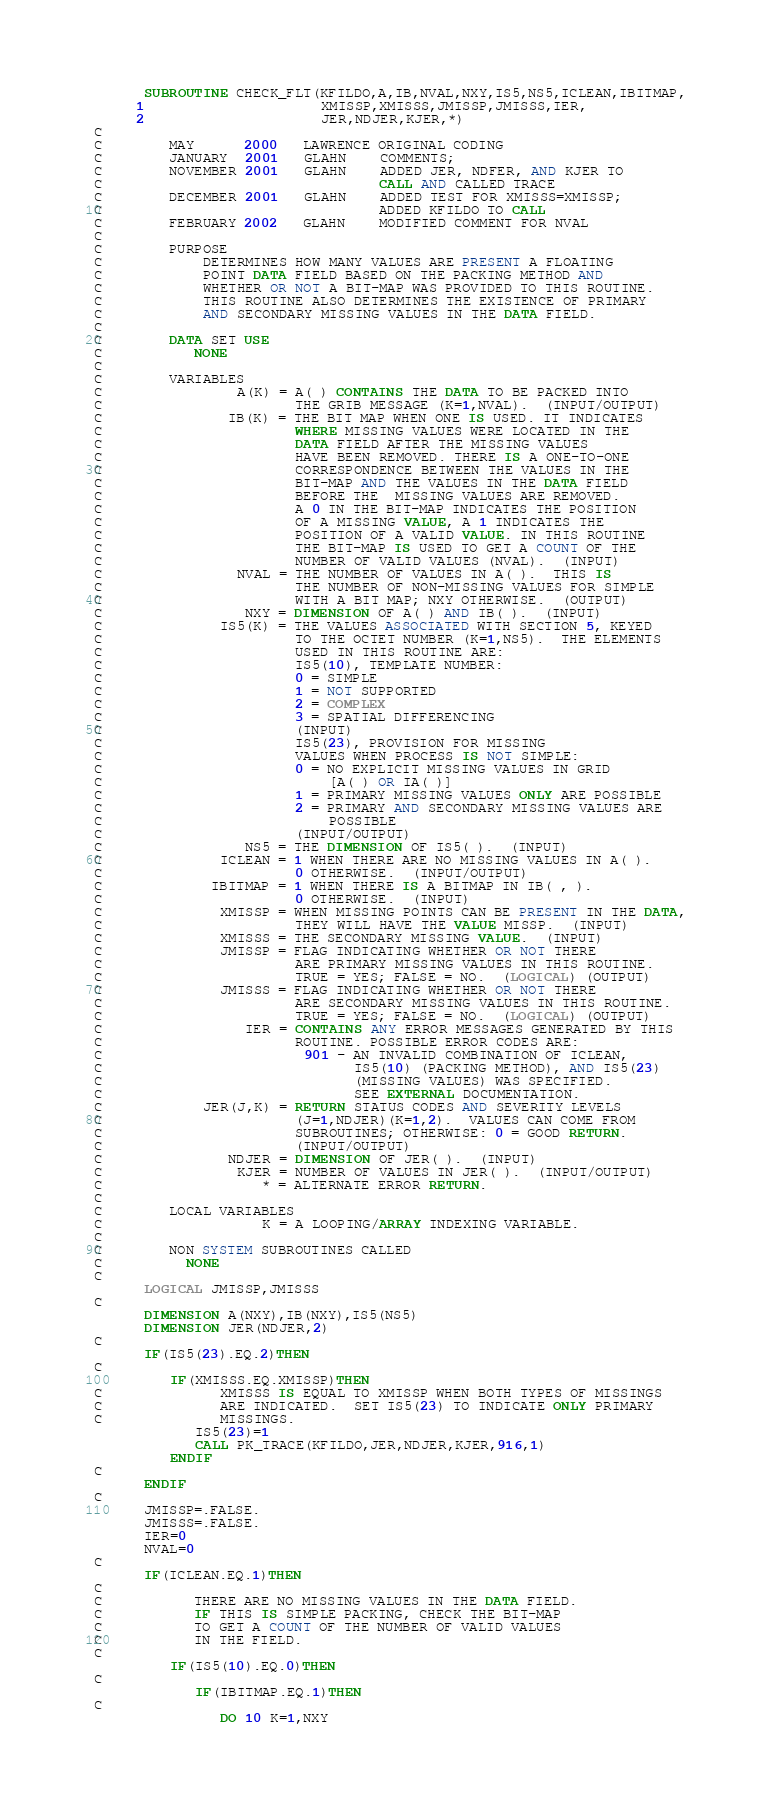<code> <loc_0><loc_0><loc_500><loc_500><_FORTRAN_>      SUBROUTINE CHECK_FLT(KFILDO,A,IB,NVAL,NXY,IS5,NS5,ICLEAN,IBITMAP,
     1                     XMISSP,XMISSS,JMISSP,JMISSS,IER,
     2                     JER,NDJER,KJER,*)
C
C        MAY      2000   LAWRENCE ORIGINAL CODING
C        JANUARY  2001   GLAHN    COMMENTS;
C        NOVEMBER 2001   GLAHN    ADDED JER, NDFER, AND KJER TO
C                                 CALL AND CALLED TRACE
C        DECEMBER 2001   GLAHN    ADDED TEST FOR XMISSS=XMISSP;
C                                 ADDED KFILDO TO CALL
C        FEBRUARY 2002   GLAHN    MODIFIED COMMENT FOR NVAL
C
C        PURPOSE
C            DETERMINES HOW MANY VALUES ARE PRESENT A FLOATING 
C            POINT DATA FIELD BASED ON THE PACKING METHOD AND
C            WHETHER OR NOT A BIT-MAP WAS PROVIDED TO THIS ROUTINE.
C            THIS ROUTINE ALSO DETERMINES THE EXISTENCE OF PRIMARY
C            AND SECONDARY MISSING VALUES IN THE DATA FIELD.
C
C        DATA SET USE
C           NONE
C
C        VARIABLES
C                A(K) = A( ) CONTAINS THE DATA TO BE PACKED INTO 
C                       THE GRIB MESSAGE (K=1,NVAL).  (INPUT/OUTPUT)
C               IB(K) = THE BIT MAP WHEN ONE IS USED. IT INDICATES
C                       WHERE MISSING VALUES WERE LOCATED IN THE 
C                       DATA FIELD AFTER THE MISSING VALUES
C                       HAVE BEEN REMOVED. THERE IS A ONE-TO-ONE
C                       CORRESPONDENCE BETWEEN THE VALUES IN THE
C                       BIT-MAP AND THE VALUES IN THE DATA FIELD
C                       BEFORE THE  MISSING VALUES ARE REMOVED.
C                       A 0 IN THE BIT-MAP INDICATES THE POSITION
C                       OF A MISSING VALUE, A 1 INDICATES THE
C                       POSITION OF A VALID VALUE. IN THIS ROUTINE
C                       THE BIT-MAP IS USED TO GET A COUNT OF THE
C                       NUMBER OF VALID VALUES (NVAL).  (INPUT)
C                NVAL = THE NUMBER OF VALUES IN A( ).  THIS IS
C                       THE NUMBER OF NON-MISSING VALUES FOR SIMPLE
C                       WITH A BIT MAP; NXY OTHERWISE.  (OUTPUT)
C                 NXY = DIMENSION OF A( ) AND IB( ).  (INPUT)
C              IS5(K) = THE VALUES ASSOCIATED WITH SECTION 5, KEYED
C                       TO THE OCTET NUMBER (K=1,NS5).  THE ELEMENTS
C                       USED IN THIS ROUTINE ARE:
C                       IS5(10), TEMPLATE NUMBER:
C                       0 = SIMPLE
C                       1 = NOT SUPPORTED
C                       2 = COMPLEX
C                       3 = SPATIAL DIFFERENCING
C                       (INPUT)
C                       IS5(23), PROVISION FOR MISSING
C                       VALUES WHEN PROCESS IS NOT SIMPLE:
C                       0 = NO EXPLICIT MISSING VALUES IN GRID 
C                           [A( ) OR IA( )]
C                       1 = PRIMARY MISSING VALUES ONLY ARE POSSIBLE
C                       2 = PRIMARY AND SECONDARY MISSING VALUES ARE
C                           POSSIBLE
C                       (INPUT/OUTPUT)
C                 NS5 = THE DIMENSION OF IS5( ).  (INPUT)
C              ICLEAN = 1 WHEN THERE ARE NO MISSING VALUES IN A( ).
C                       0 OTHERWISE.  (INPUT/OUTPUT)
C             IBITMAP = 1 WHEN THERE IS A BITMAP IN IB( , ).
C                       0 OTHERWISE.  (INPUT)
C              XMISSP = WHEN MISSING POINTS CAN BE PRESENT IN THE DATA,
C                       THEY WILL HAVE THE VALUE MISSP.  (INPUT)
C              XMISSS = THE SECONDARY MISSING VALUE.  (INPUT)
C              JMISSP = FLAG INDICATING WHETHER OR NOT THERE
C                       ARE PRIMARY MISSING VALUES IN THIS ROUTINE.
C                       TRUE = YES; FALSE = NO.  (LOGICAL) (OUTPUT)
C              JMISSS = FLAG INDICATING WHETHER OR NOT THERE
C                       ARE SECONDARY MISSING VALUES IN THIS ROUTINE.
C                       TRUE = YES; FALSE = NO.  (LOGICAL) (OUTPUT)
C                 IER = CONTAINS ANY ERROR MESSAGES GENERATED BY THIS
C                       ROUTINE. POSSIBLE ERROR CODES ARE:
C                        901 - AN INVALID COMBINATION OF ICLEAN, 
C                              IS5(10) (PACKING METHOD), AND IS5(23)
C                              (MISSING VALUES) WAS SPECIFIED.
C                              SEE EXTERNAL DOCUMENTATION.
C            JER(J,K) = RETURN STATUS CODES AND SEVERITY LEVELS
C                       (J=1,NDJER)(K=1,2).  VALUES CAN COME FROM
C                       SUBROUTINES; OTHERWISE: 0 = GOOD RETURN.
C                       (INPUT/OUTPUT)
C               NDJER = DIMENSION OF JER( ).  (INPUT)
C                KJER = NUMBER OF VALUES IN JER( ).  (INPUT/OUTPUT)
C                   * = ALTERNATE ERROR RETURN.
C
C        LOCAL VARIABLES
C                   K = A LOOPING/ARRAY INDEXING VARIABLE.
C
C        NON SYSTEM SUBROUTINES CALLED
C          NONE 
C
      LOGICAL JMISSP,JMISSS
C
      DIMENSION A(NXY),IB(NXY),IS5(NS5)
      DIMENSION JER(NDJER,2)
C
      IF(IS5(23).EQ.2)THEN
C
         IF(XMISSS.EQ.XMISSP)THEN
C              XMISSS IS EQUAL TO XMISSP WHEN BOTH TYPES OF MISSINGS
C              ARE INDICATED.  SET IS5(23) TO INDICATE ONLY PRIMARY
C              MISSINGS.
            IS5(23)=1
            CALL PK_TRACE(KFILDO,JER,NDJER,KJER,916,1)
         ENDIF
C  
      ENDIF
C          
      JMISSP=.FALSE.
      JMISSS=.FALSE.
      IER=0
      NVAL=0
C
      IF(ICLEAN.EQ.1)THEN
C
C           THERE ARE NO MISSING VALUES IN THE DATA FIELD.
C           IF THIS IS SIMPLE PACKING, CHECK THE BIT-MAP
C           TO GET A COUNT OF THE NUMBER OF VALID VALUES
C           IN THE FIELD.
C   
         IF(IS5(10).EQ.0)THEN
C
            IF(IBITMAP.EQ.1)THEN
C
               DO 10 K=1,NXY</code> 